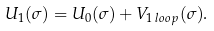<formula> <loc_0><loc_0><loc_500><loc_500>U _ { 1 } ( \sigma ) = U _ { 0 } ( \sigma ) + V _ { 1 \, l o o p } ( \sigma ) .</formula> 